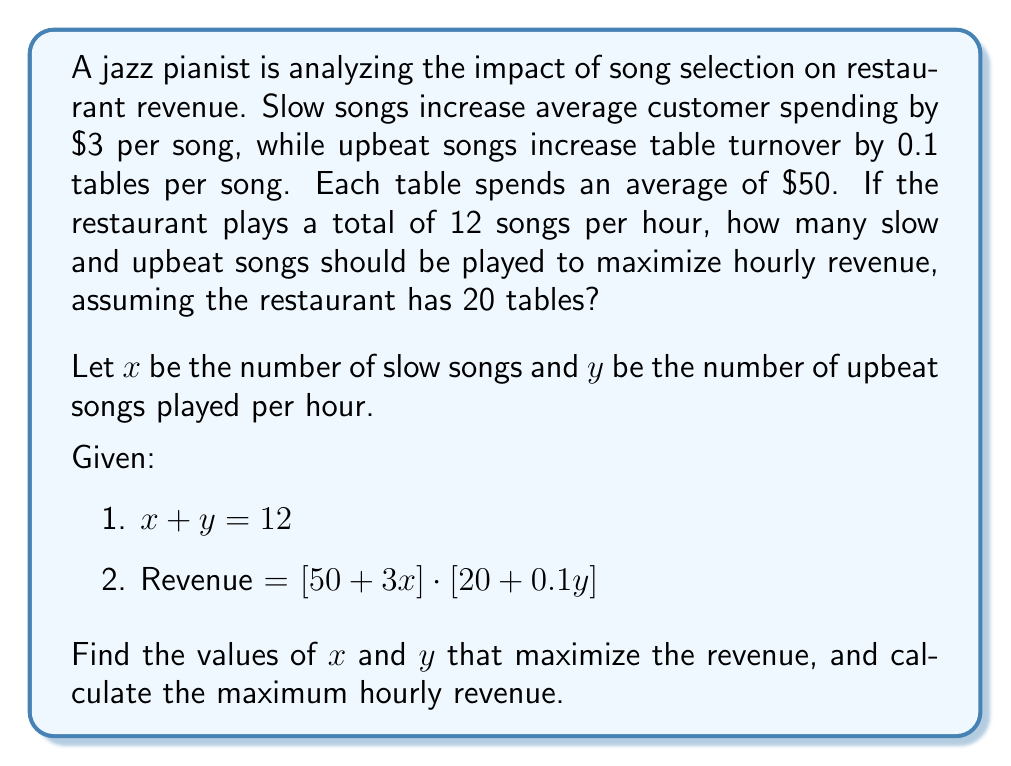Provide a solution to this math problem. To solve this problem, we'll use the following steps:

1) First, we need to express the revenue function in terms of a single variable. We can use the first equation to substitute $y = 12 - x$ into the revenue function:

   Revenue = $[50 + 3x] \cdot [20 + 0.1(12-x)]$
            = $[50 + 3x] \cdot [21.2 - 0.1x]$

2) Expand this expression:
   Revenue = $(50 + 3x)(21.2 - 0.1x)$
            = $1060 - 5x + 63.6x - 0.3x^2$
            = $1060 + 58.6x - 0.3x^2$

3) To find the maximum revenue, we need to find where the derivative of this function equals zero:

   $\frac{dR}{dx} = 58.6 - 0.6x$

   Set this equal to zero:
   $58.6 - 0.6x = 0$
   $58.6 = 0.6x$
   $x = 97.67$

4) However, since $x$ must be a whole number and cannot exceed 12, we need to check the revenue at $x = 9$ and $x = 10$:

   For $x = 9$:
   Revenue = $1060 + 58.6(9) - 0.3(9^2) = 1526.3$

   For $x = 10$:
   Revenue = $1060 + 58.6(10) - 0.3(10^2) = 1526$

5) Therefore, the maximum revenue occurs when $x = 9$ (slow songs) and $y = 3$ (upbeat songs).

6) The maximum hourly revenue is $1526.30.
Answer: The restaurant should play 9 slow songs and 3 upbeat songs per hour to maximize revenue. The maximum hourly revenue is $1526.30. 